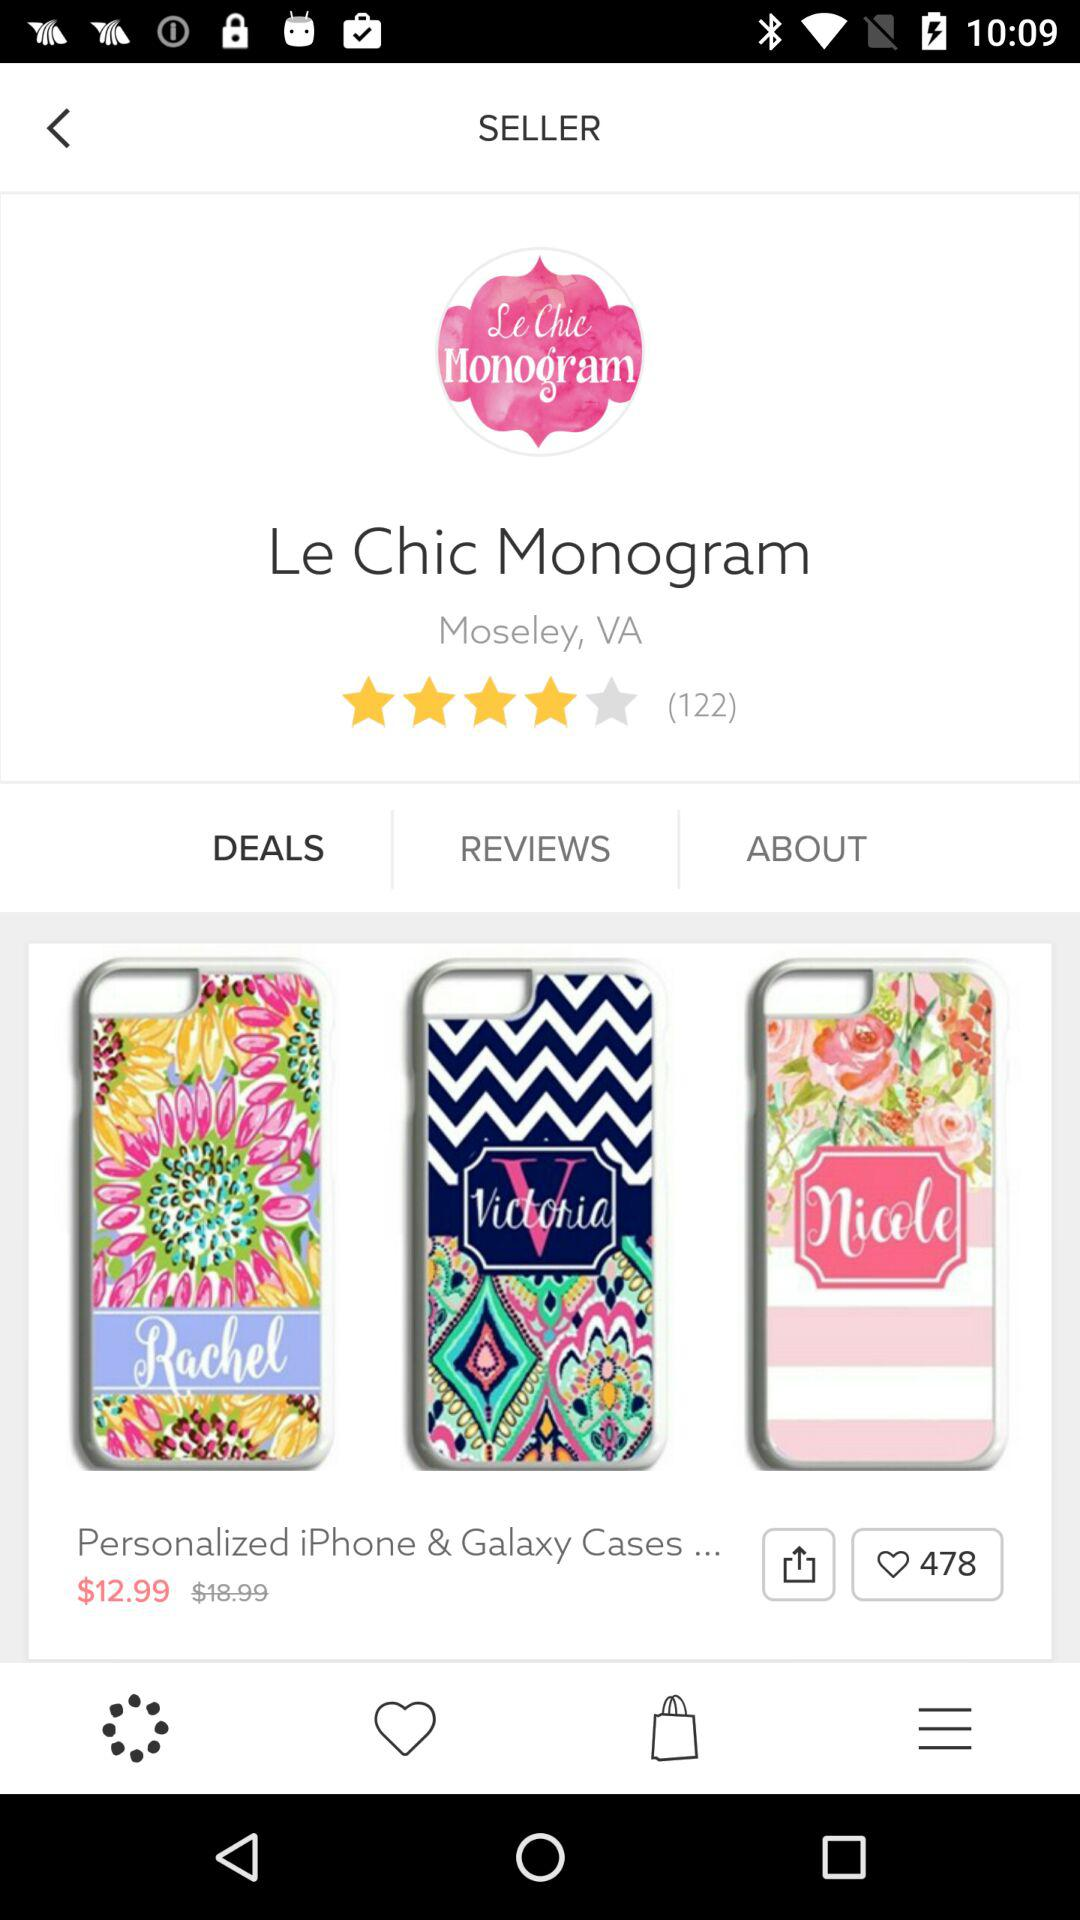How many reviews does the seller have?
Answer the question using a single word or phrase. 122 